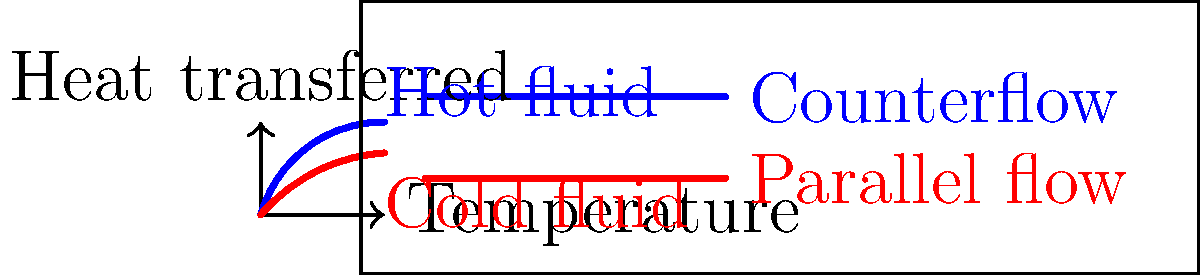As a political analyst from Malta analyzing the economic impact of industrial efficiency, you come across a report on heat exchanger configurations. Based on the temperature-heat transfer diagram shown, which configuration (counterflow or parallel flow) would likely result in higher thermal efficiency and potentially lower energy costs for Maltese industries? To answer this question, we need to analyze the temperature-heat transfer diagram and understand the implications for thermal efficiency:

1. The blue curve represents the hot fluid, and the red curve represents the cold fluid for both configurations.

2. Counterflow configuration (blue curve):
   - The temperature difference between hot and cold fluids remains relatively constant throughout the heat exchanger.
   - This results in a more uniform heat transfer rate and a larger overall temperature change for both fluids.

3. Parallel flow configuration (red curve):
   - The temperature difference between hot and cold fluids decreases along the length of the heat exchanger.
   - This leads to a less efficient heat transfer, especially towards the end of the exchanger.

4. Thermal efficiency comparison:
   - Counterflow configuration allows for a greater temperature change in both fluids.
   - This means more heat is transferred from the hot fluid to the cold fluid in the counterflow arrangement.

5. Economic implications:
   - Higher thermal efficiency translates to better energy utilization.
   - This can lead to lower energy consumption and reduced operational costs for industries.

6. Relevance to Malta:
   - As an island nation, Malta may have higher energy costs due to limited domestic energy resources.
   - Implementing more efficient heat exchanger designs could help reduce energy consumption in various industries, potentially improving economic competitiveness.

Therefore, the counterflow configuration would likely result in higher thermal efficiency and potentially lower energy costs for Maltese industries.
Answer: Counterflow configuration 